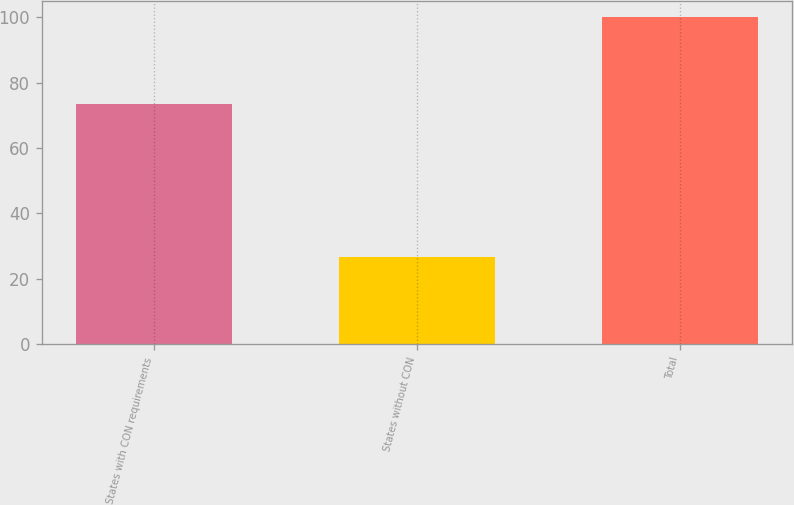<chart> <loc_0><loc_0><loc_500><loc_500><bar_chart><fcel>States with CON requirements<fcel>States without CON<fcel>Total<nl><fcel>73.4<fcel>26.6<fcel>100<nl></chart> 